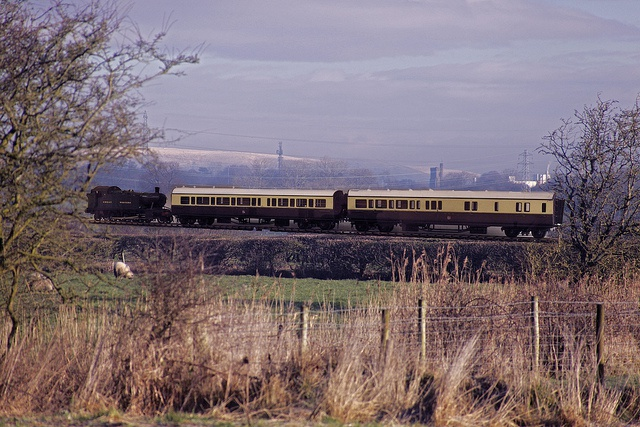Describe the objects in this image and their specific colors. I can see a train in gray, black, tan, and darkgray tones in this image. 